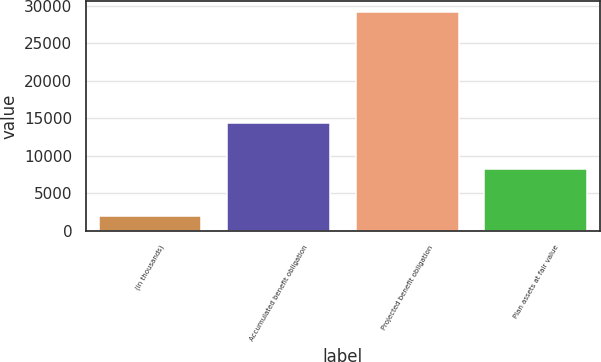Convert chart. <chart><loc_0><loc_0><loc_500><loc_500><bar_chart><fcel>(in thousands)<fcel>Accumulated benefit obligation<fcel>Projected benefit obligation<fcel>Plan assets at fair value<nl><fcel>2008<fcel>14347<fcel>29190<fcel>8320<nl></chart> 